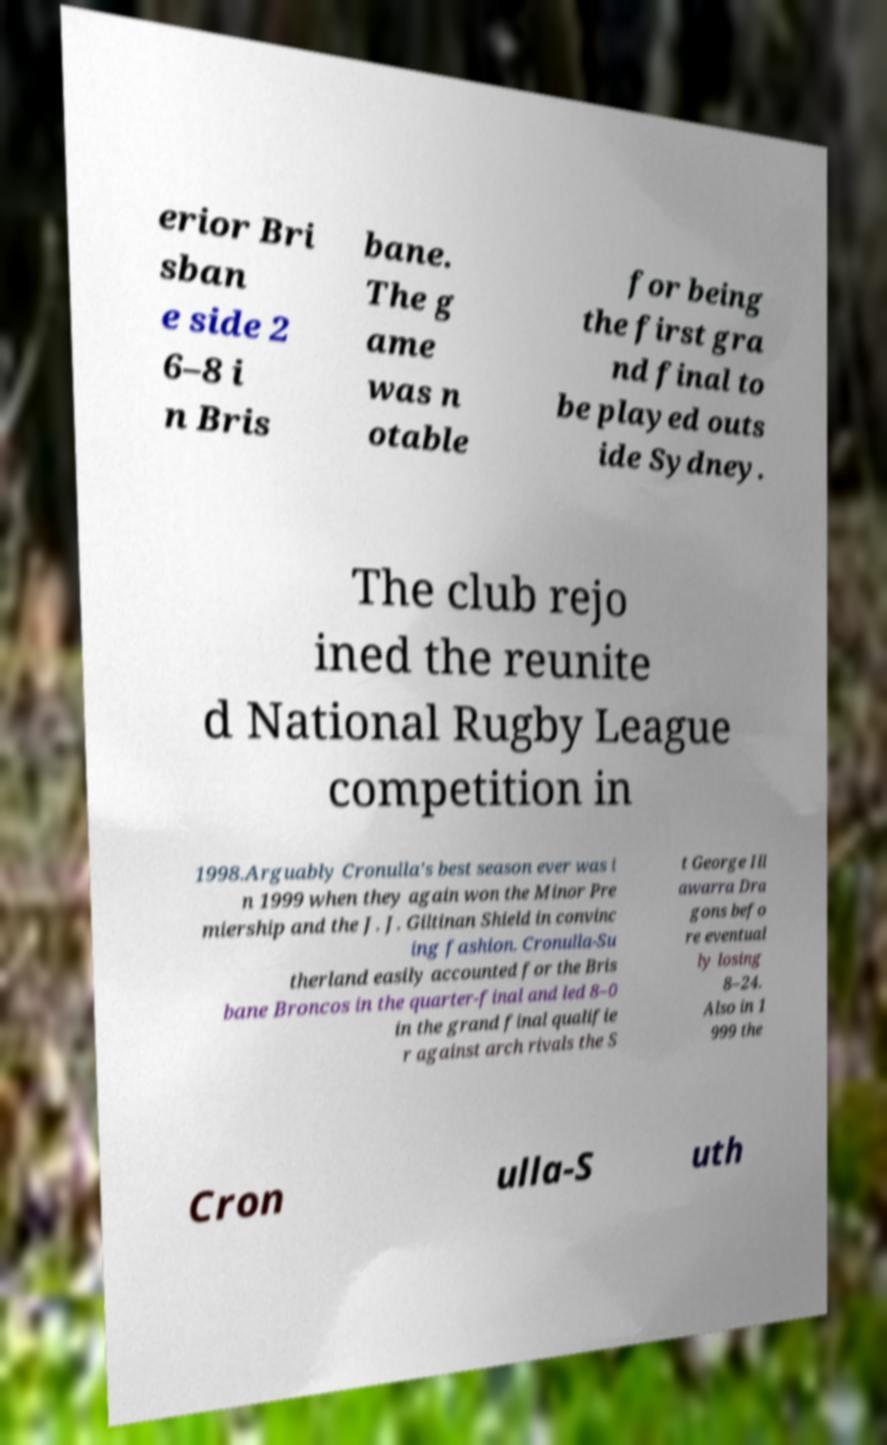Can you read and provide the text displayed in the image?This photo seems to have some interesting text. Can you extract and type it out for me? erior Bri sban e side 2 6–8 i n Bris bane. The g ame was n otable for being the first gra nd final to be played outs ide Sydney. The club rejo ined the reunite d National Rugby League competition in 1998.Arguably Cronulla's best season ever was i n 1999 when they again won the Minor Pre miership and the J. J. Giltinan Shield in convinc ing fashion. Cronulla-Su therland easily accounted for the Bris bane Broncos in the quarter-final and led 8–0 in the grand final qualifie r against arch rivals the S t George Ill awarra Dra gons befo re eventual ly losing 8–24. Also in 1 999 the Cron ulla-S uth 